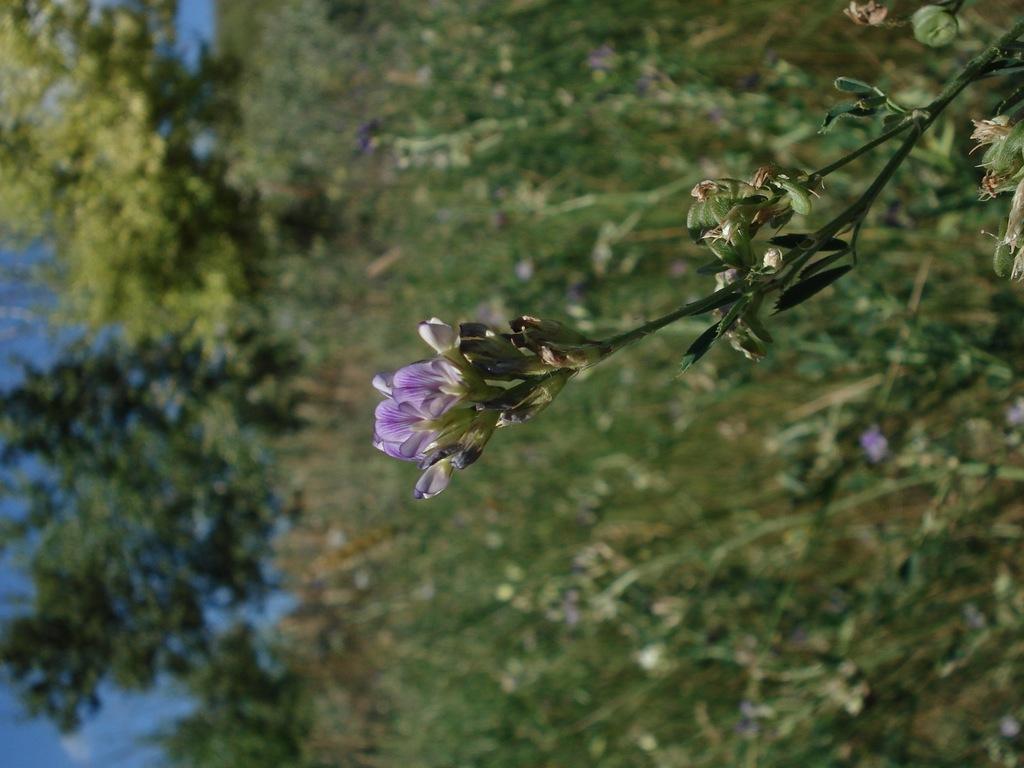Can you describe this image briefly? In the middle there are flowers and buds to the plant, on the left side there are trees and there is the sky in this image. 